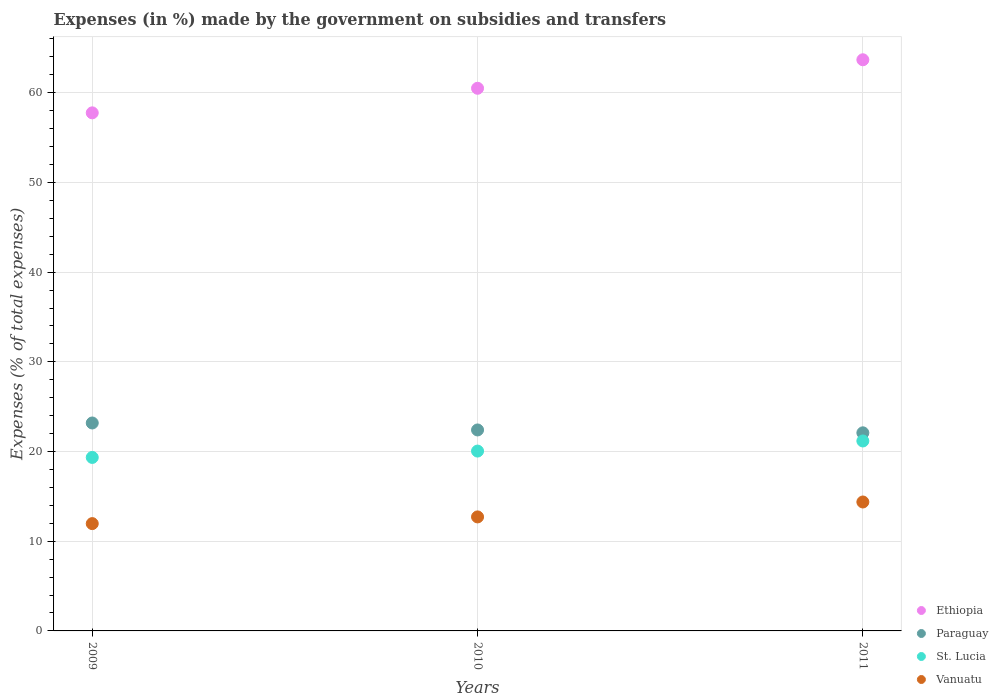Is the number of dotlines equal to the number of legend labels?
Provide a succinct answer. Yes. What is the percentage of expenses made by the government on subsidies and transfers in Vanuatu in 2009?
Provide a succinct answer. 11.96. Across all years, what is the maximum percentage of expenses made by the government on subsidies and transfers in Vanuatu?
Make the answer very short. 14.37. Across all years, what is the minimum percentage of expenses made by the government on subsidies and transfers in St. Lucia?
Your answer should be very brief. 19.34. In which year was the percentage of expenses made by the government on subsidies and transfers in Ethiopia minimum?
Provide a succinct answer. 2009. What is the total percentage of expenses made by the government on subsidies and transfers in St. Lucia in the graph?
Provide a short and direct response. 60.57. What is the difference between the percentage of expenses made by the government on subsidies and transfers in Ethiopia in 2010 and that in 2011?
Your answer should be very brief. -3.18. What is the difference between the percentage of expenses made by the government on subsidies and transfers in St. Lucia in 2011 and the percentage of expenses made by the government on subsidies and transfers in Paraguay in 2010?
Make the answer very short. -1.23. What is the average percentage of expenses made by the government on subsidies and transfers in Ethiopia per year?
Make the answer very short. 60.64. In the year 2011, what is the difference between the percentage of expenses made by the government on subsidies and transfers in Ethiopia and percentage of expenses made by the government on subsidies and transfers in St. Lucia?
Give a very brief answer. 42.5. In how many years, is the percentage of expenses made by the government on subsidies and transfers in Paraguay greater than 30 %?
Offer a terse response. 0. What is the ratio of the percentage of expenses made by the government on subsidies and transfers in St. Lucia in 2009 to that in 2010?
Offer a very short reply. 0.96. Is the percentage of expenses made by the government on subsidies and transfers in Paraguay in 2009 less than that in 2011?
Offer a terse response. No. Is the difference between the percentage of expenses made by the government on subsidies and transfers in Ethiopia in 2009 and 2010 greater than the difference between the percentage of expenses made by the government on subsidies and transfers in St. Lucia in 2009 and 2010?
Your answer should be compact. No. What is the difference between the highest and the second highest percentage of expenses made by the government on subsidies and transfers in Ethiopia?
Give a very brief answer. 3.18. What is the difference between the highest and the lowest percentage of expenses made by the government on subsidies and transfers in Vanuatu?
Offer a terse response. 2.41. In how many years, is the percentage of expenses made by the government on subsidies and transfers in Vanuatu greater than the average percentage of expenses made by the government on subsidies and transfers in Vanuatu taken over all years?
Keep it short and to the point. 1. Is it the case that in every year, the sum of the percentage of expenses made by the government on subsidies and transfers in Paraguay and percentage of expenses made by the government on subsidies and transfers in St. Lucia  is greater than the sum of percentage of expenses made by the government on subsidies and transfers in Ethiopia and percentage of expenses made by the government on subsidies and transfers in Vanuatu?
Offer a very short reply. Yes. Is it the case that in every year, the sum of the percentage of expenses made by the government on subsidies and transfers in St. Lucia and percentage of expenses made by the government on subsidies and transfers in Vanuatu  is greater than the percentage of expenses made by the government on subsidies and transfers in Ethiopia?
Offer a very short reply. No. Does the percentage of expenses made by the government on subsidies and transfers in St. Lucia monotonically increase over the years?
Offer a very short reply. Yes. Is the percentage of expenses made by the government on subsidies and transfers in St. Lucia strictly less than the percentage of expenses made by the government on subsidies and transfers in Ethiopia over the years?
Provide a short and direct response. Yes. How many years are there in the graph?
Make the answer very short. 3. What is the difference between two consecutive major ticks on the Y-axis?
Make the answer very short. 10. Are the values on the major ticks of Y-axis written in scientific E-notation?
Keep it short and to the point. No. Does the graph contain any zero values?
Give a very brief answer. No. Where does the legend appear in the graph?
Keep it short and to the point. Bottom right. How many legend labels are there?
Your response must be concise. 4. What is the title of the graph?
Give a very brief answer. Expenses (in %) made by the government on subsidies and transfers. What is the label or title of the Y-axis?
Your answer should be very brief. Expenses (% of total expenses). What is the Expenses (% of total expenses) of Ethiopia in 2009?
Provide a short and direct response. 57.76. What is the Expenses (% of total expenses) in Paraguay in 2009?
Your response must be concise. 23.18. What is the Expenses (% of total expenses) of St. Lucia in 2009?
Your response must be concise. 19.34. What is the Expenses (% of total expenses) in Vanuatu in 2009?
Provide a succinct answer. 11.96. What is the Expenses (% of total expenses) of Ethiopia in 2010?
Make the answer very short. 60.5. What is the Expenses (% of total expenses) of Paraguay in 2010?
Your answer should be compact. 22.4. What is the Expenses (% of total expenses) of St. Lucia in 2010?
Make the answer very short. 20.05. What is the Expenses (% of total expenses) in Vanuatu in 2010?
Keep it short and to the point. 12.71. What is the Expenses (% of total expenses) of Ethiopia in 2011?
Offer a very short reply. 63.67. What is the Expenses (% of total expenses) of Paraguay in 2011?
Your response must be concise. 22.09. What is the Expenses (% of total expenses) in St. Lucia in 2011?
Your answer should be compact. 21.18. What is the Expenses (% of total expenses) in Vanuatu in 2011?
Give a very brief answer. 14.37. Across all years, what is the maximum Expenses (% of total expenses) in Ethiopia?
Offer a very short reply. 63.67. Across all years, what is the maximum Expenses (% of total expenses) in Paraguay?
Offer a very short reply. 23.18. Across all years, what is the maximum Expenses (% of total expenses) of St. Lucia?
Your answer should be very brief. 21.18. Across all years, what is the maximum Expenses (% of total expenses) in Vanuatu?
Make the answer very short. 14.37. Across all years, what is the minimum Expenses (% of total expenses) in Ethiopia?
Provide a short and direct response. 57.76. Across all years, what is the minimum Expenses (% of total expenses) of Paraguay?
Offer a terse response. 22.09. Across all years, what is the minimum Expenses (% of total expenses) of St. Lucia?
Offer a terse response. 19.34. Across all years, what is the minimum Expenses (% of total expenses) in Vanuatu?
Keep it short and to the point. 11.96. What is the total Expenses (% of total expenses) in Ethiopia in the graph?
Give a very brief answer. 181.93. What is the total Expenses (% of total expenses) in Paraguay in the graph?
Your response must be concise. 67.67. What is the total Expenses (% of total expenses) in St. Lucia in the graph?
Offer a very short reply. 60.57. What is the total Expenses (% of total expenses) in Vanuatu in the graph?
Offer a terse response. 39.05. What is the difference between the Expenses (% of total expenses) of Ethiopia in 2009 and that in 2010?
Make the answer very short. -2.74. What is the difference between the Expenses (% of total expenses) of Paraguay in 2009 and that in 2010?
Keep it short and to the point. 0.78. What is the difference between the Expenses (% of total expenses) in St. Lucia in 2009 and that in 2010?
Your response must be concise. -0.71. What is the difference between the Expenses (% of total expenses) of Vanuatu in 2009 and that in 2010?
Keep it short and to the point. -0.75. What is the difference between the Expenses (% of total expenses) in Ethiopia in 2009 and that in 2011?
Offer a very short reply. -5.92. What is the difference between the Expenses (% of total expenses) in Paraguay in 2009 and that in 2011?
Your answer should be compact. 1.1. What is the difference between the Expenses (% of total expenses) of St. Lucia in 2009 and that in 2011?
Ensure brevity in your answer.  -1.83. What is the difference between the Expenses (% of total expenses) of Vanuatu in 2009 and that in 2011?
Your response must be concise. -2.41. What is the difference between the Expenses (% of total expenses) in Ethiopia in 2010 and that in 2011?
Keep it short and to the point. -3.18. What is the difference between the Expenses (% of total expenses) in Paraguay in 2010 and that in 2011?
Your answer should be very brief. 0.32. What is the difference between the Expenses (% of total expenses) in St. Lucia in 2010 and that in 2011?
Offer a terse response. -1.13. What is the difference between the Expenses (% of total expenses) of Vanuatu in 2010 and that in 2011?
Your response must be concise. -1.66. What is the difference between the Expenses (% of total expenses) in Ethiopia in 2009 and the Expenses (% of total expenses) in Paraguay in 2010?
Your answer should be very brief. 35.35. What is the difference between the Expenses (% of total expenses) of Ethiopia in 2009 and the Expenses (% of total expenses) of St. Lucia in 2010?
Ensure brevity in your answer.  37.71. What is the difference between the Expenses (% of total expenses) of Ethiopia in 2009 and the Expenses (% of total expenses) of Vanuatu in 2010?
Keep it short and to the point. 45.05. What is the difference between the Expenses (% of total expenses) in Paraguay in 2009 and the Expenses (% of total expenses) in St. Lucia in 2010?
Give a very brief answer. 3.13. What is the difference between the Expenses (% of total expenses) of Paraguay in 2009 and the Expenses (% of total expenses) of Vanuatu in 2010?
Your answer should be very brief. 10.47. What is the difference between the Expenses (% of total expenses) of St. Lucia in 2009 and the Expenses (% of total expenses) of Vanuatu in 2010?
Ensure brevity in your answer.  6.63. What is the difference between the Expenses (% of total expenses) in Ethiopia in 2009 and the Expenses (% of total expenses) in Paraguay in 2011?
Ensure brevity in your answer.  35.67. What is the difference between the Expenses (% of total expenses) of Ethiopia in 2009 and the Expenses (% of total expenses) of St. Lucia in 2011?
Ensure brevity in your answer.  36.58. What is the difference between the Expenses (% of total expenses) in Ethiopia in 2009 and the Expenses (% of total expenses) in Vanuatu in 2011?
Provide a succinct answer. 43.38. What is the difference between the Expenses (% of total expenses) in Paraguay in 2009 and the Expenses (% of total expenses) in St. Lucia in 2011?
Your response must be concise. 2.01. What is the difference between the Expenses (% of total expenses) of Paraguay in 2009 and the Expenses (% of total expenses) of Vanuatu in 2011?
Your response must be concise. 8.81. What is the difference between the Expenses (% of total expenses) in St. Lucia in 2009 and the Expenses (% of total expenses) in Vanuatu in 2011?
Provide a succinct answer. 4.97. What is the difference between the Expenses (% of total expenses) of Ethiopia in 2010 and the Expenses (% of total expenses) of Paraguay in 2011?
Your answer should be very brief. 38.41. What is the difference between the Expenses (% of total expenses) in Ethiopia in 2010 and the Expenses (% of total expenses) in St. Lucia in 2011?
Your response must be concise. 39.32. What is the difference between the Expenses (% of total expenses) in Ethiopia in 2010 and the Expenses (% of total expenses) in Vanuatu in 2011?
Your answer should be compact. 46.12. What is the difference between the Expenses (% of total expenses) in Paraguay in 2010 and the Expenses (% of total expenses) in St. Lucia in 2011?
Your answer should be very brief. 1.23. What is the difference between the Expenses (% of total expenses) of Paraguay in 2010 and the Expenses (% of total expenses) of Vanuatu in 2011?
Your answer should be very brief. 8.03. What is the difference between the Expenses (% of total expenses) in St. Lucia in 2010 and the Expenses (% of total expenses) in Vanuatu in 2011?
Make the answer very short. 5.68. What is the average Expenses (% of total expenses) of Ethiopia per year?
Offer a terse response. 60.64. What is the average Expenses (% of total expenses) of Paraguay per year?
Give a very brief answer. 22.56. What is the average Expenses (% of total expenses) in St. Lucia per year?
Offer a very short reply. 20.19. What is the average Expenses (% of total expenses) in Vanuatu per year?
Offer a terse response. 13.02. In the year 2009, what is the difference between the Expenses (% of total expenses) in Ethiopia and Expenses (% of total expenses) in Paraguay?
Your answer should be very brief. 34.58. In the year 2009, what is the difference between the Expenses (% of total expenses) in Ethiopia and Expenses (% of total expenses) in St. Lucia?
Provide a short and direct response. 38.42. In the year 2009, what is the difference between the Expenses (% of total expenses) of Ethiopia and Expenses (% of total expenses) of Vanuatu?
Your response must be concise. 45.79. In the year 2009, what is the difference between the Expenses (% of total expenses) in Paraguay and Expenses (% of total expenses) in St. Lucia?
Ensure brevity in your answer.  3.84. In the year 2009, what is the difference between the Expenses (% of total expenses) of Paraguay and Expenses (% of total expenses) of Vanuatu?
Provide a succinct answer. 11.22. In the year 2009, what is the difference between the Expenses (% of total expenses) of St. Lucia and Expenses (% of total expenses) of Vanuatu?
Your answer should be very brief. 7.38. In the year 2010, what is the difference between the Expenses (% of total expenses) of Ethiopia and Expenses (% of total expenses) of Paraguay?
Your response must be concise. 38.09. In the year 2010, what is the difference between the Expenses (% of total expenses) of Ethiopia and Expenses (% of total expenses) of St. Lucia?
Offer a very short reply. 40.45. In the year 2010, what is the difference between the Expenses (% of total expenses) of Ethiopia and Expenses (% of total expenses) of Vanuatu?
Make the answer very short. 47.79. In the year 2010, what is the difference between the Expenses (% of total expenses) of Paraguay and Expenses (% of total expenses) of St. Lucia?
Ensure brevity in your answer.  2.36. In the year 2010, what is the difference between the Expenses (% of total expenses) of Paraguay and Expenses (% of total expenses) of Vanuatu?
Make the answer very short. 9.69. In the year 2010, what is the difference between the Expenses (% of total expenses) of St. Lucia and Expenses (% of total expenses) of Vanuatu?
Give a very brief answer. 7.34. In the year 2011, what is the difference between the Expenses (% of total expenses) of Ethiopia and Expenses (% of total expenses) of Paraguay?
Offer a terse response. 41.59. In the year 2011, what is the difference between the Expenses (% of total expenses) in Ethiopia and Expenses (% of total expenses) in St. Lucia?
Offer a terse response. 42.5. In the year 2011, what is the difference between the Expenses (% of total expenses) of Ethiopia and Expenses (% of total expenses) of Vanuatu?
Provide a succinct answer. 49.3. In the year 2011, what is the difference between the Expenses (% of total expenses) of Paraguay and Expenses (% of total expenses) of St. Lucia?
Your answer should be very brief. 0.91. In the year 2011, what is the difference between the Expenses (% of total expenses) in Paraguay and Expenses (% of total expenses) in Vanuatu?
Your answer should be very brief. 7.71. In the year 2011, what is the difference between the Expenses (% of total expenses) of St. Lucia and Expenses (% of total expenses) of Vanuatu?
Your answer should be compact. 6.8. What is the ratio of the Expenses (% of total expenses) in Ethiopia in 2009 to that in 2010?
Your response must be concise. 0.95. What is the ratio of the Expenses (% of total expenses) of Paraguay in 2009 to that in 2010?
Offer a terse response. 1.03. What is the ratio of the Expenses (% of total expenses) of St. Lucia in 2009 to that in 2010?
Make the answer very short. 0.96. What is the ratio of the Expenses (% of total expenses) of Ethiopia in 2009 to that in 2011?
Your response must be concise. 0.91. What is the ratio of the Expenses (% of total expenses) of Paraguay in 2009 to that in 2011?
Your answer should be compact. 1.05. What is the ratio of the Expenses (% of total expenses) of St. Lucia in 2009 to that in 2011?
Make the answer very short. 0.91. What is the ratio of the Expenses (% of total expenses) of Vanuatu in 2009 to that in 2011?
Your response must be concise. 0.83. What is the ratio of the Expenses (% of total expenses) in Ethiopia in 2010 to that in 2011?
Ensure brevity in your answer.  0.95. What is the ratio of the Expenses (% of total expenses) of Paraguay in 2010 to that in 2011?
Make the answer very short. 1.01. What is the ratio of the Expenses (% of total expenses) of St. Lucia in 2010 to that in 2011?
Keep it short and to the point. 0.95. What is the ratio of the Expenses (% of total expenses) of Vanuatu in 2010 to that in 2011?
Ensure brevity in your answer.  0.88. What is the difference between the highest and the second highest Expenses (% of total expenses) of Ethiopia?
Your answer should be compact. 3.18. What is the difference between the highest and the second highest Expenses (% of total expenses) in Paraguay?
Provide a short and direct response. 0.78. What is the difference between the highest and the second highest Expenses (% of total expenses) in St. Lucia?
Your answer should be compact. 1.13. What is the difference between the highest and the second highest Expenses (% of total expenses) of Vanuatu?
Keep it short and to the point. 1.66. What is the difference between the highest and the lowest Expenses (% of total expenses) in Ethiopia?
Give a very brief answer. 5.92. What is the difference between the highest and the lowest Expenses (% of total expenses) of Paraguay?
Your answer should be very brief. 1.1. What is the difference between the highest and the lowest Expenses (% of total expenses) of St. Lucia?
Make the answer very short. 1.83. What is the difference between the highest and the lowest Expenses (% of total expenses) of Vanuatu?
Provide a succinct answer. 2.41. 